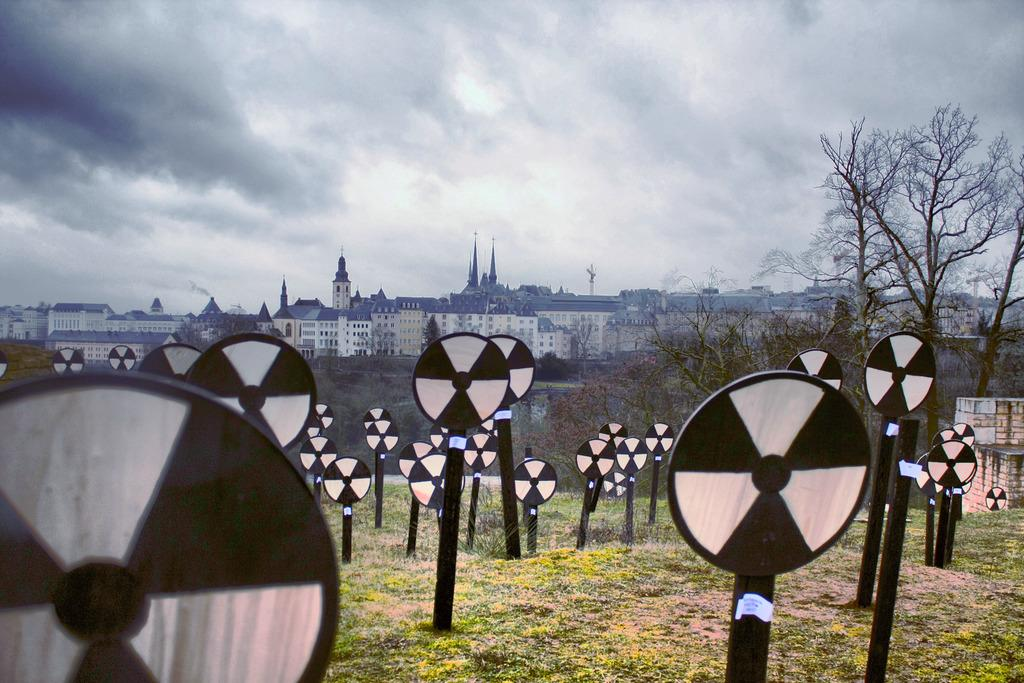What type of objects are covered in black and white paint in the image? There are boards with black and white paint in the image. What can be seen in the background behind the boards? Trees and buildings are visible behind the boards. What type of corn is growing on the chin of the person in the image? There is no person or corn present in the image; it features boards with black and white paint and a background with trees and buildings. 